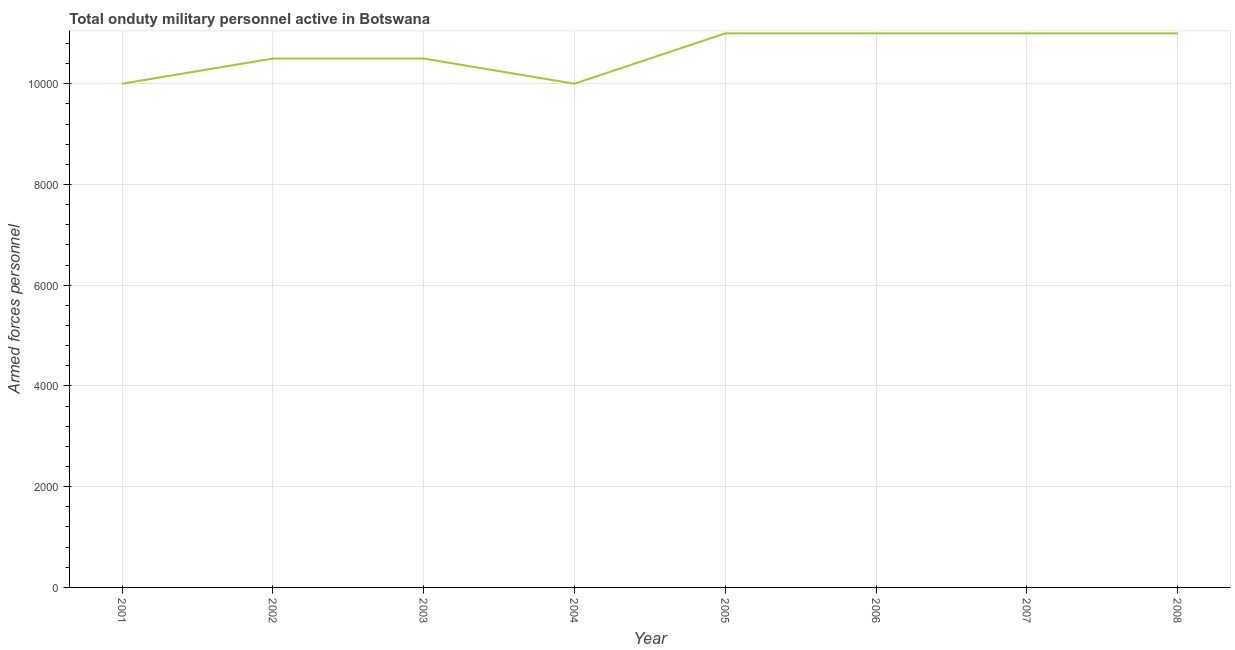What is the number of armed forces personnel in 2001?
Provide a succinct answer. 10000. Across all years, what is the maximum number of armed forces personnel?
Your response must be concise. 1.10e+04. Across all years, what is the minimum number of armed forces personnel?
Make the answer very short. 10000. In which year was the number of armed forces personnel maximum?
Your answer should be compact. 2005. What is the sum of the number of armed forces personnel?
Provide a short and direct response. 8.50e+04. What is the difference between the number of armed forces personnel in 2004 and 2008?
Ensure brevity in your answer.  -1000. What is the average number of armed forces personnel per year?
Make the answer very short. 1.06e+04. What is the median number of armed forces personnel?
Provide a succinct answer. 1.08e+04. In how many years, is the number of armed forces personnel greater than 10000 ?
Offer a very short reply. 6. Do a majority of the years between 2005 and 2008 (inclusive) have number of armed forces personnel greater than 5200 ?
Provide a succinct answer. Yes. What is the ratio of the number of armed forces personnel in 2002 to that in 2008?
Offer a terse response. 0.95. Is the difference between the number of armed forces personnel in 2002 and 2006 greater than the difference between any two years?
Your answer should be very brief. No. What is the difference between the highest and the lowest number of armed forces personnel?
Make the answer very short. 1000. Does the number of armed forces personnel monotonically increase over the years?
Provide a short and direct response. No. How many lines are there?
Offer a very short reply. 1. How many years are there in the graph?
Make the answer very short. 8. What is the difference between two consecutive major ticks on the Y-axis?
Ensure brevity in your answer.  2000. What is the title of the graph?
Offer a terse response. Total onduty military personnel active in Botswana. What is the label or title of the Y-axis?
Make the answer very short. Armed forces personnel. What is the Armed forces personnel of 2002?
Provide a succinct answer. 1.05e+04. What is the Armed forces personnel in 2003?
Provide a succinct answer. 1.05e+04. What is the Armed forces personnel in 2005?
Ensure brevity in your answer.  1.10e+04. What is the Armed forces personnel in 2006?
Your response must be concise. 1.10e+04. What is the Armed forces personnel of 2007?
Give a very brief answer. 1.10e+04. What is the Armed forces personnel in 2008?
Ensure brevity in your answer.  1.10e+04. What is the difference between the Armed forces personnel in 2001 and 2002?
Keep it short and to the point. -500. What is the difference between the Armed forces personnel in 2001 and 2003?
Offer a very short reply. -500. What is the difference between the Armed forces personnel in 2001 and 2005?
Give a very brief answer. -1000. What is the difference between the Armed forces personnel in 2001 and 2006?
Your answer should be very brief. -1000. What is the difference between the Armed forces personnel in 2001 and 2007?
Offer a terse response. -1000. What is the difference between the Armed forces personnel in 2001 and 2008?
Keep it short and to the point. -1000. What is the difference between the Armed forces personnel in 2002 and 2005?
Make the answer very short. -500. What is the difference between the Armed forces personnel in 2002 and 2006?
Provide a short and direct response. -500. What is the difference between the Armed forces personnel in 2002 and 2007?
Provide a succinct answer. -500. What is the difference between the Armed forces personnel in 2002 and 2008?
Keep it short and to the point. -500. What is the difference between the Armed forces personnel in 2003 and 2005?
Provide a short and direct response. -500. What is the difference between the Armed forces personnel in 2003 and 2006?
Your answer should be compact. -500. What is the difference between the Armed forces personnel in 2003 and 2007?
Offer a very short reply. -500. What is the difference between the Armed forces personnel in 2003 and 2008?
Your answer should be very brief. -500. What is the difference between the Armed forces personnel in 2004 and 2005?
Your answer should be compact. -1000. What is the difference between the Armed forces personnel in 2004 and 2006?
Give a very brief answer. -1000. What is the difference between the Armed forces personnel in 2004 and 2007?
Provide a short and direct response. -1000. What is the difference between the Armed forces personnel in 2004 and 2008?
Provide a short and direct response. -1000. What is the difference between the Armed forces personnel in 2005 and 2007?
Make the answer very short. 0. What is the difference between the Armed forces personnel in 2006 and 2008?
Give a very brief answer. 0. What is the difference between the Armed forces personnel in 2007 and 2008?
Offer a terse response. 0. What is the ratio of the Armed forces personnel in 2001 to that in 2002?
Your answer should be compact. 0.95. What is the ratio of the Armed forces personnel in 2001 to that in 2004?
Make the answer very short. 1. What is the ratio of the Armed forces personnel in 2001 to that in 2005?
Offer a very short reply. 0.91. What is the ratio of the Armed forces personnel in 2001 to that in 2006?
Your answer should be very brief. 0.91. What is the ratio of the Armed forces personnel in 2001 to that in 2007?
Offer a very short reply. 0.91. What is the ratio of the Armed forces personnel in 2001 to that in 2008?
Offer a very short reply. 0.91. What is the ratio of the Armed forces personnel in 2002 to that in 2003?
Make the answer very short. 1. What is the ratio of the Armed forces personnel in 2002 to that in 2004?
Provide a succinct answer. 1.05. What is the ratio of the Armed forces personnel in 2002 to that in 2005?
Provide a short and direct response. 0.95. What is the ratio of the Armed forces personnel in 2002 to that in 2006?
Provide a short and direct response. 0.95. What is the ratio of the Armed forces personnel in 2002 to that in 2007?
Provide a short and direct response. 0.95. What is the ratio of the Armed forces personnel in 2002 to that in 2008?
Offer a very short reply. 0.95. What is the ratio of the Armed forces personnel in 2003 to that in 2005?
Your answer should be compact. 0.95. What is the ratio of the Armed forces personnel in 2003 to that in 2006?
Keep it short and to the point. 0.95. What is the ratio of the Armed forces personnel in 2003 to that in 2007?
Keep it short and to the point. 0.95. What is the ratio of the Armed forces personnel in 2003 to that in 2008?
Keep it short and to the point. 0.95. What is the ratio of the Armed forces personnel in 2004 to that in 2005?
Your answer should be very brief. 0.91. What is the ratio of the Armed forces personnel in 2004 to that in 2006?
Your answer should be compact. 0.91. What is the ratio of the Armed forces personnel in 2004 to that in 2007?
Provide a short and direct response. 0.91. What is the ratio of the Armed forces personnel in 2004 to that in 2008?
Provide a short and direct response. 0.91. What is the ratio of the Armed forces personnel in 2005 to that in 2007?
Give a very brief answer. 1. What is the ratio of the Armed forces personnel in 2005 to that in 2008?
Provide a succinct answer. 1. What is the ratio of the Armed forces personnel in 2006 to that in 2007?
Give a very brief answer. 1. What is the ratio of the Armed forces personnel in 2006 to that in 2008?
Provide a short and direct response. 1. 